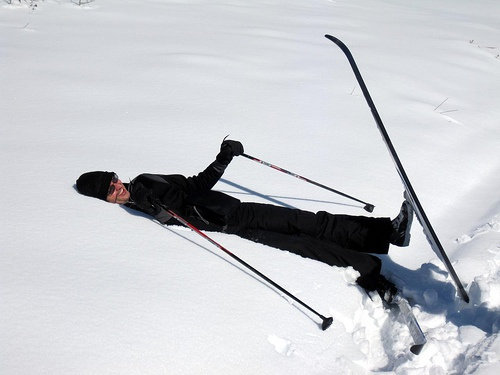Describe the objects in this image and their specific colors. I can see people in lightgray, black, gray, and darkgray tones and skis in lightgray, black, darkgray, and gray tones in this image. 